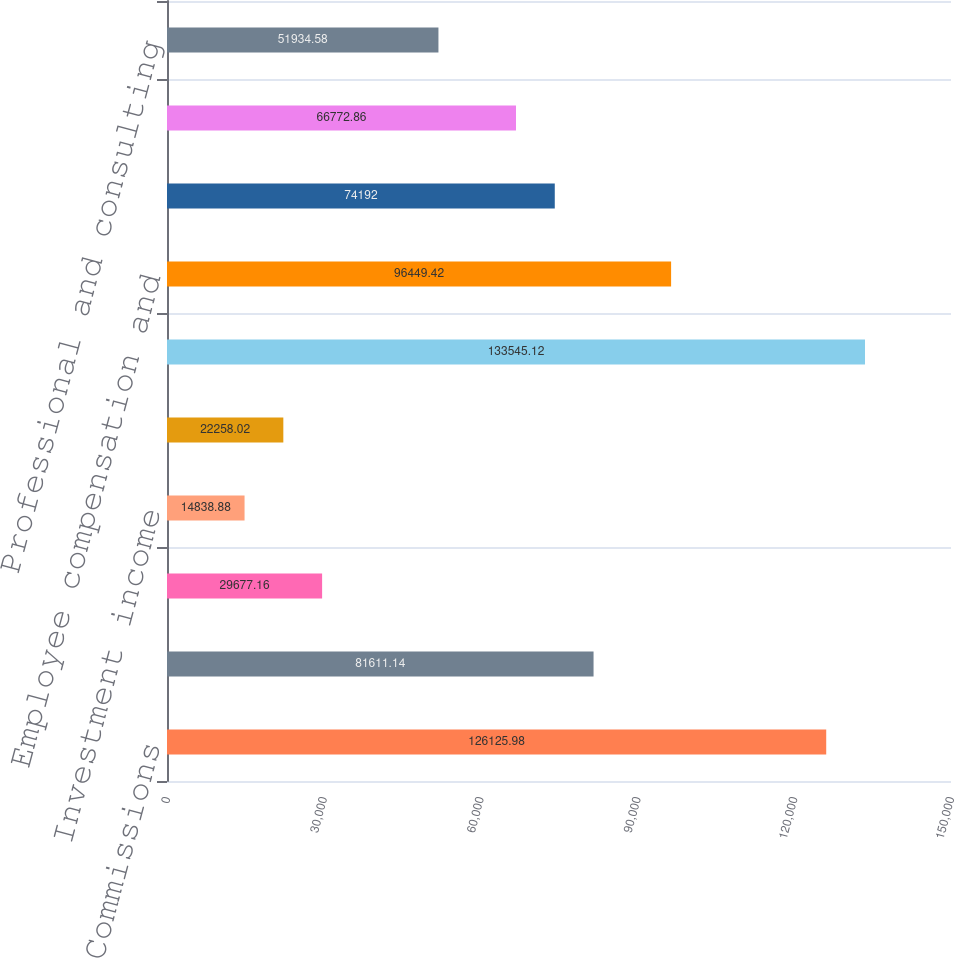Convert chart to OTSL. <chart><loc_0><loc_0><loc_500><loc_500><bar_chart><fcel>Commissions<fcel>Information and post-trade<fcel>Technology products and<fcel>Investment income<fcel>Other<fcel>Total revenues<fcel>Employee compensation and<fcel>Depreciation and amortization<fcel>Technology and communications<fcel>Professional and consulting<nl><fcel>126126<fcel>81611.1<fcel>29677.2<fcel>14838.9<fcel>22258<fcel>133545<fcel>96449.4<fcel>74192<fcel>66772.9<fcel>51934.6<nl></chart> 